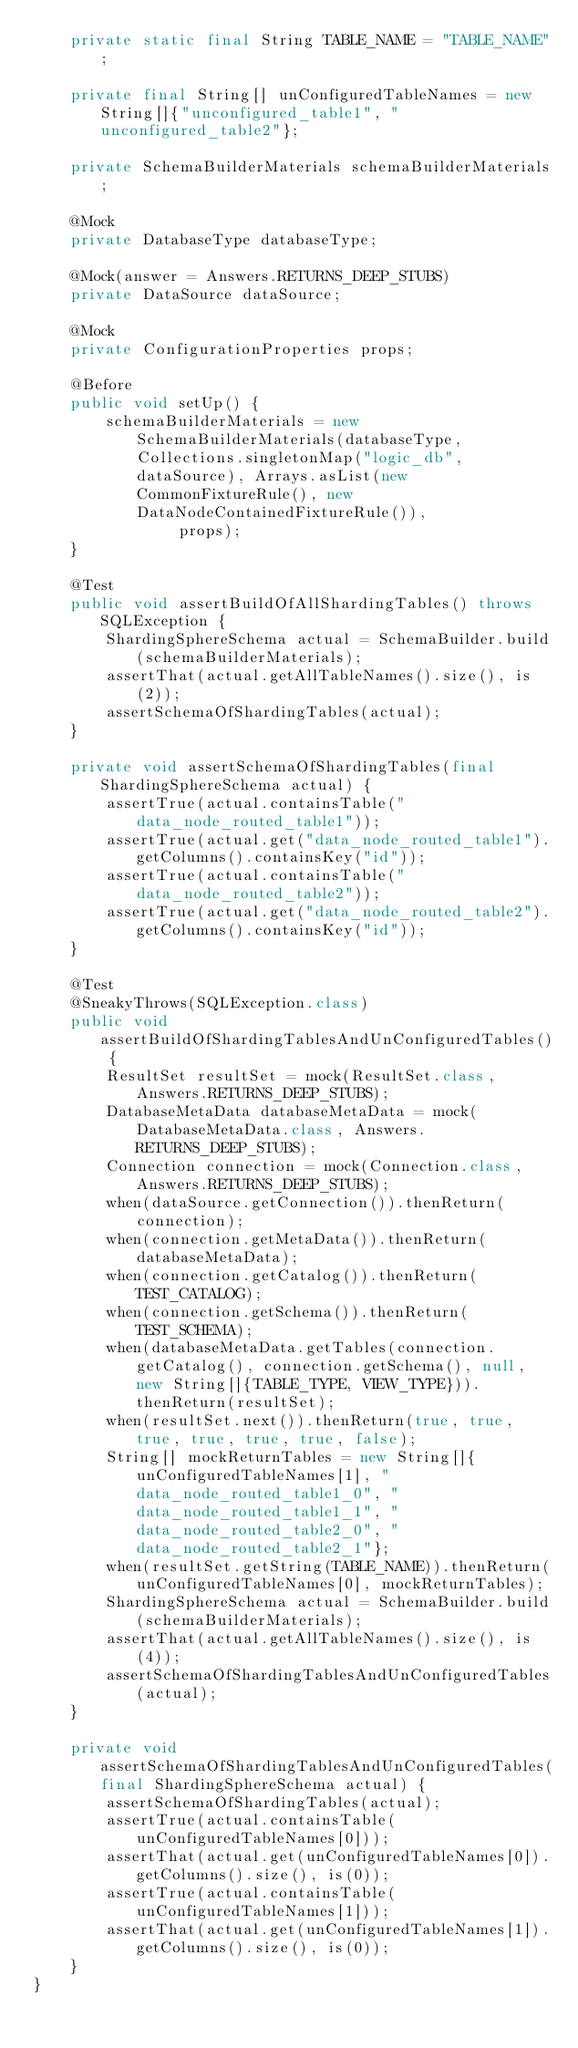Convert code to text. <code><loc_0><loc_0><loc_500><loc_500><_Java_>    private static final String TABLE_NAME = "TABLE_NAME";

    private final String[] unConfiguredTableNames = new String[]{"unconfigured_table1", "unconfigured_table2"};

    private SchemaBuilderMaterials schemaBuilderMaterials;

    @Mock
    private DatabaseType databaseType;

    @Mock(answer = Answers.RETURNS_DEEP_STUBS)
    private DataSource dataSource;

    @Mock
    private ConfigurationProperties props;

    @Before
    public void setUp() {
        schemaBuilderMaterials = new SchemaBuilderMaterials(databaseType, Collections.singletonMap("logic_db", dataSource), Arrays.asList(new CommonFixtureRule(), new DataNodeContainedFixtureRule()),
                props);
    }

    @Test
    public void assertBuildOfAllShardingTables() throws SQLException {
        ShardingSphereSchema actual = SchemaBuilder.build(schemaBuilderMaterials);
        assertThat(actual.getAllTableNames().size(), is(2));
        assertSchemaOfShardingTables(actual);
    }

    private void assertSchemaOfShardingTables(final ShardingSphereSchema actual) {
        assertTrue(actual.containsTable("data_node_routed_table1"));
        assertTrue(actual.get("data_node_routed_table1").getColumns().containsKey("id"));
        assertTrue(actual.containsTable("data_node_routed_table2"));
        assertTrue(actual.get("data_node_routed_table2").getColumns().containsKey("id"));
    }

    @Test
    @SneakyThrows(SQLException.class)
    public void assertBuildOfShardingTablesAndUnConfiguredTables() {
        ResultSet resultSet = mock(ResultSet.class, Answers.RETURNS_DEEP_STUBS);
        DatabaseMetaData databaseMetaData = mock(DatabaseMetaData.class, Answers.RETURNS_DEEP_STUBS);
        Connection connection = mock(Connection.class, Answers.RETURNS_DEEP_STUBS);
        when(dataSource.getConnection()).thenReturn(connection);
        when(connection.getMetaData()).thenReturn(databaseMetaData);
        when(connection.getCatalog()).thenReturn(TEST_CATALOG);
        when(connection.getSchema()).thenReturn(TEST_SCHEMA);
        when(databaseMetaData.getTables(connection.getCatalog(), connection.getSchema(), null, new String[]{TABLE_TYPE, VIEW_TYPE})).thenReturn(resultSet);
        when(resultSet.next()).thenReturn(true, true, true, true, true, true, false);
        String[] mockReturnTables = new String[]{unConfiguredTableNames[1], "data_node_routed_table1_0", "data_node_routed_table1_1", "data_node_routed_table2_0", "data_node_routed_table2_1"};
        when(resultSet.getString(TABLE_NAME)).thenReturn(unConfiguredTableNames[0], mockReturnTables);
        ShardingSphereSchema actual = SchemaBuilder.build(schemaBuilderMaterials);
        assertThat(actual.getAllTableNames().size(), is(4));
        assertSchemaOfShardingTablesAndUnConfiguredTables(actual);
    }

    private void assertSchemaOfShardingTablesAndUnConfiguredTables(final ShardingSphereSchema actual) {
        assertSchemaOfShardingTables(actual);
        assertTrue(actual.containsTable(unConfiguredTableNames[0]));
        assertThat(actual.get(unConfiguredTableNames[0]).getColumns().size(), is(0));
        assertTrue(actual.containsTable(unConfiguredTableNames[1]));
        assertThat(actual.get(unConfiguredTableNames[1]).getColumns().size(), is(0));
    }
}
</code> 